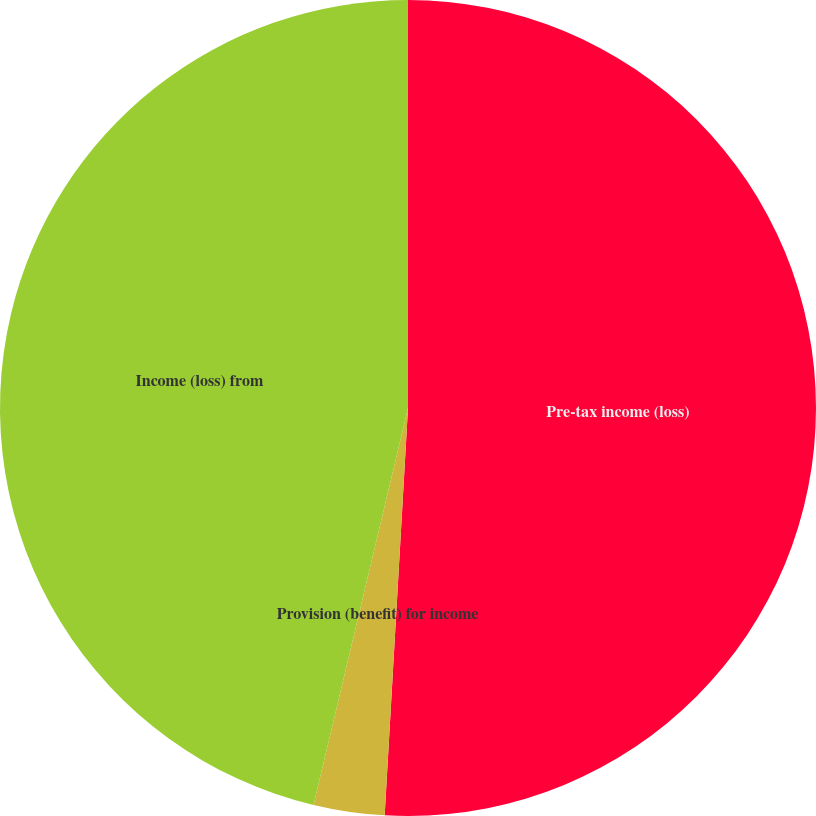Convert chart to OTSL. <chart><loc_0><loc_0><loc_500><loc_500><pie_chart><fcel>Pre-tax income (loss)<fcel>Provision (benefit) for income<fcel>Income (loss) from<nl><fcel>50.91%<fcel>2.81%<fcel>46.28%<nl></chart> 